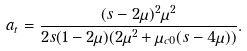Convert formula to latex. <formula><loc_0><loc_0><loc_500><loc_500>a _ { t } = \frac { ( s - 2 \mu ) ^ { 2 } \mu ^ { 2 } } { 2 s ( 1 - 2 \mu ) ( 2 \mu ^ { 2 } + \mu _ { c 0 } ( s - 4 \mu ) ) } .</formula> 